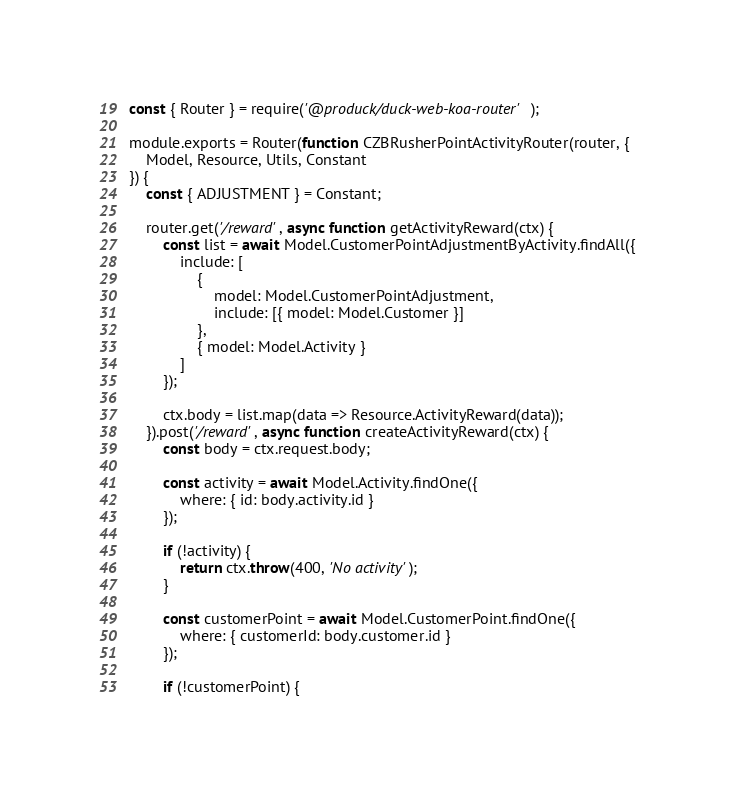Convert code to text. <code><loc_0><loc_0><loc_500><loc_500><_JavaScript_>const { Router } = require('@produck/duck-web-koa-router');

module.exports = Router(function CZBRusherPointActivityRouter(router, {
	Model, Resource, Utils, Constant
}) {
	const { ADJUSTMENT } = Constant;

	router.get('/reward', async function getActivityReward(ctx) {
		const list = await Model.CustomerPointAdjustmentByActivity.findAll({
			include: [
				{
					model: Model.CustomerPointAdjustment,
					include: [{ model: Model.Customer }]
				},
				{ model: Model.Activity }
			]
		});

		ctx.body = list.map(data => Resource.ActivityReward(data));
	}).post('/reward', async function createActivityReward(ctx) {
		const body = ctx.request.body;

		const activity = await Model.Activity.findOne({
			where: { id: body.activity.id }
		});

		if (!activity) {
			return ctx.throw(400, 'No activity');
		}

		const customerPoint = await Model.CustomerPoint.findOne({
			where: { customerId: body.customer.id }
		});

		if (!customerPoint) {</code> 